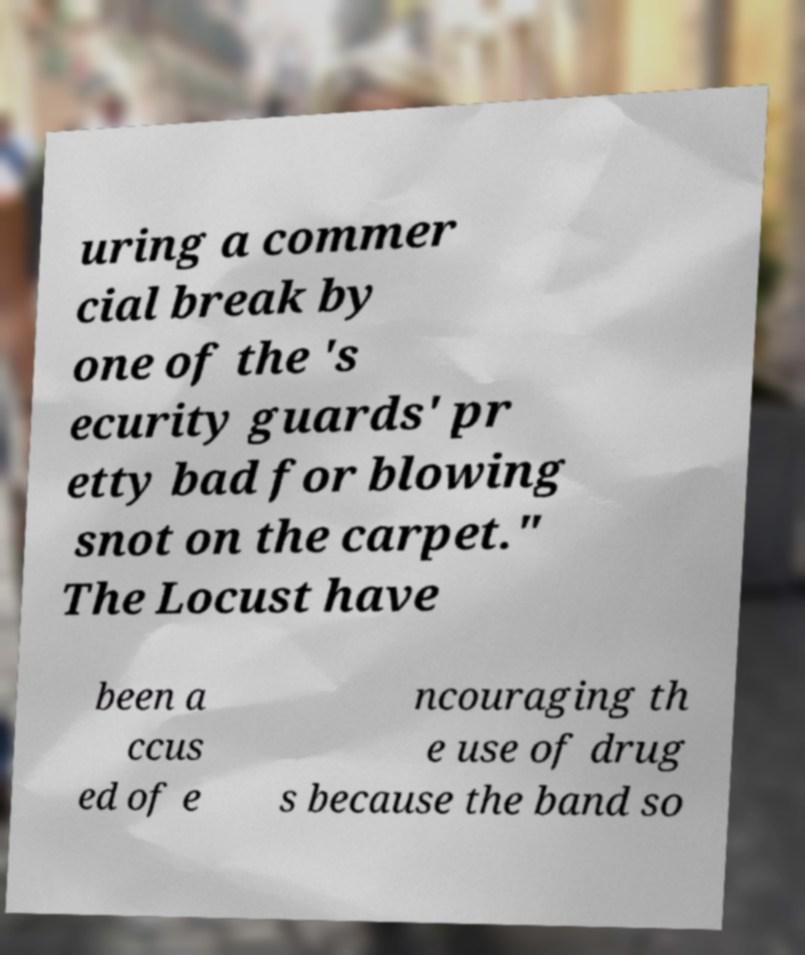There's text embedded in this image that I need extracted. Can you transcribe it verbatim? uring a commer cial break by one of the 's ecurity guards' pr etty bad for blowing snot on the carpet." The Locust have been a ccus ed of e ncouraging th e use of drug s because the band so 